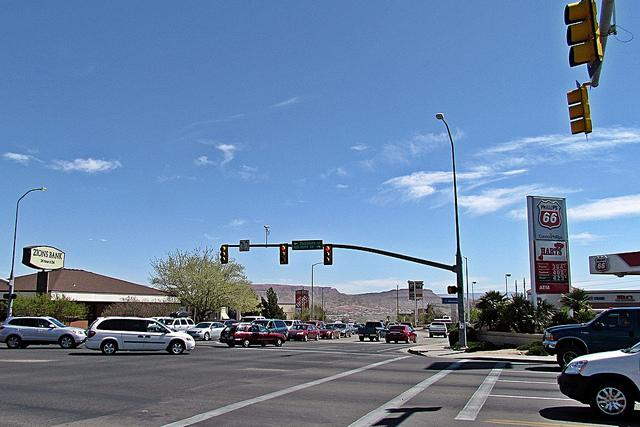What type of station is nearby? Please explain your reasoning. gas. Phillips 66 is a gas station so that's the closest type of "station" that can be seen. 